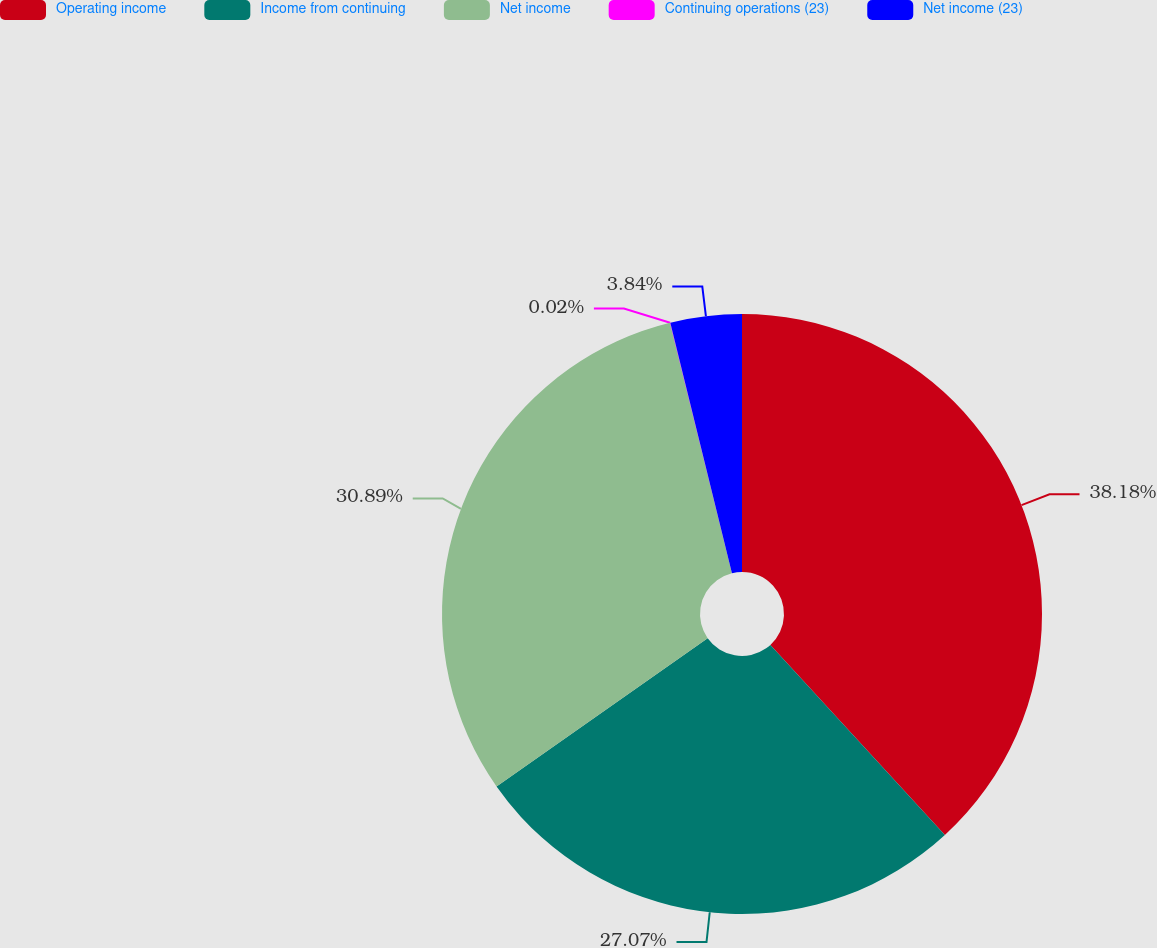Convert chart to OTSL. <chart><loc_0><loc_0><loc_500><loc_500><pie_chart><fcel>Operating income<fcel>Income from continuing<fcel>Net income<fcel>Continuing operations (23)<fcel>Net income (23)<nl><fcel>38.18%<fcel>27.07%<fcel>30.89%<fcel>0.02%<fcel>3.84%<nl></chart> 